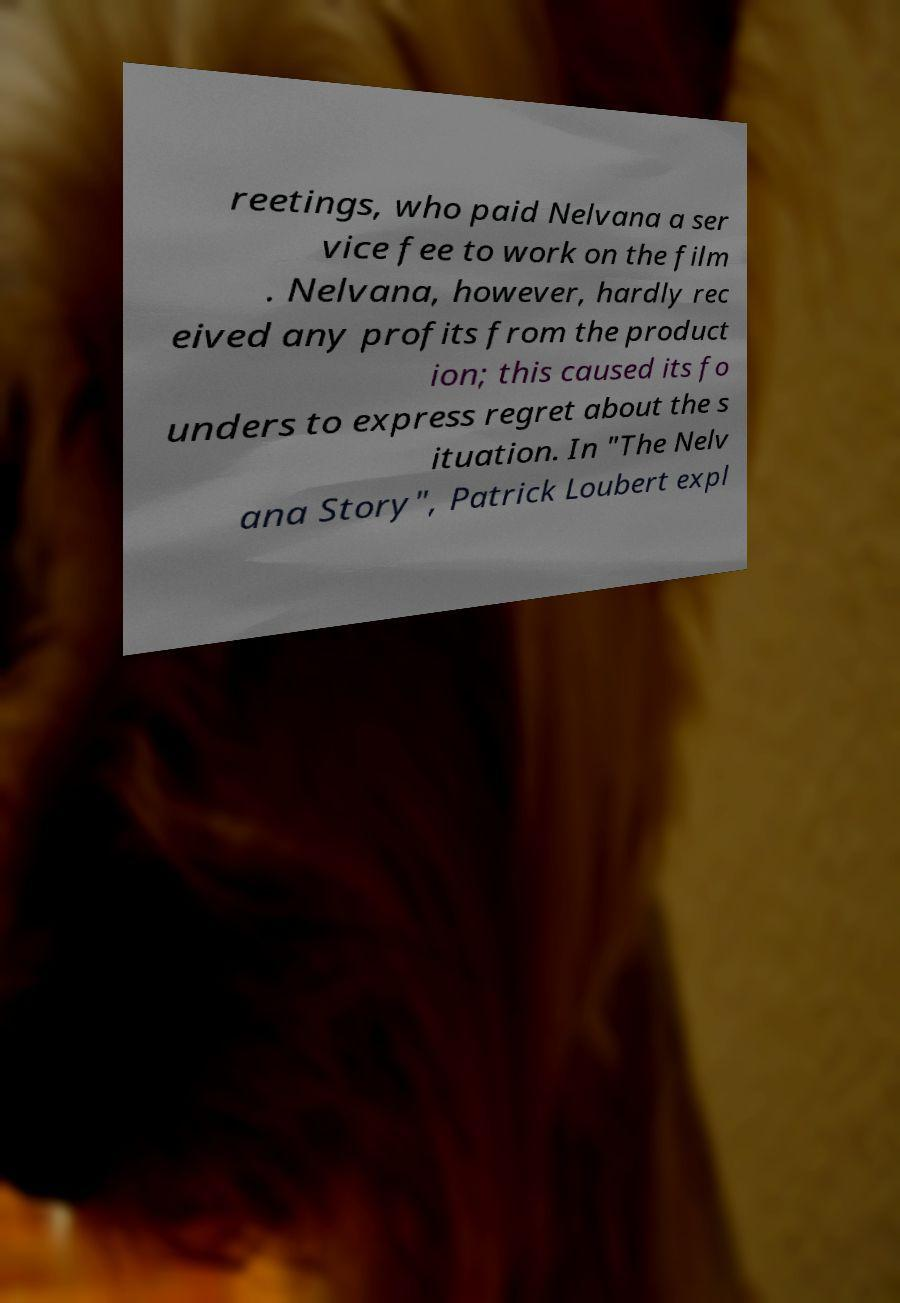What messages or text are displayed in this image? I need them in a readable, typed format. reetings, who paid Nelvana a ser vice fee to work on the film . Nelvana, however, hardly rec eived any profits from the product ion; this caused its fo unders to express regret about the s ituation. In "The Nelv ana Story", Patrick Loubert expl 